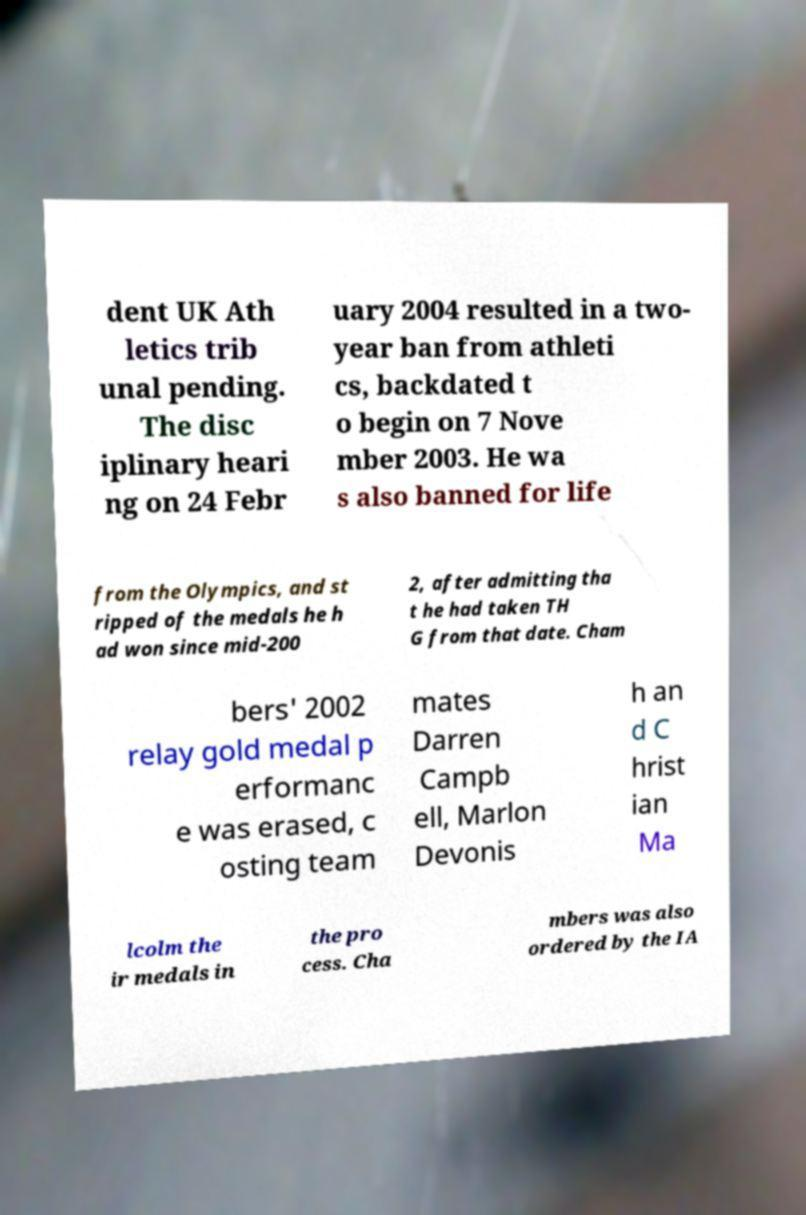Could you assist in decoding the text presented in this image and type it out clearly? dent UK Ath letics trib unal pending. The disc iplinary heari ng on 24 Febr uary 2004 resulted in a two- year ban from athleti cs, backdated t o begin on 7 Nove mber 2003. He wa s also banned for life from the Olympics, and st ripped of the medals he h ad won since mid-200 2, after admitting tha t he had taken TH G from that date. Cham bers' 2002 relay gold medal p erformanc e was erased, c osting team mates Darren Campb ell, Marlon Devonis h an d C hrist ian Ma lcolm the ir medals in the pro cess. Cha mbers was also ordered by the IA 